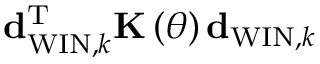<formula> <loc_0><loc_0><loc_500><loc_500>{ d } _ { W I N , k } ^ { T } { K } \left ( \theta \right ) { d } _ { W I N , k }</formula> 